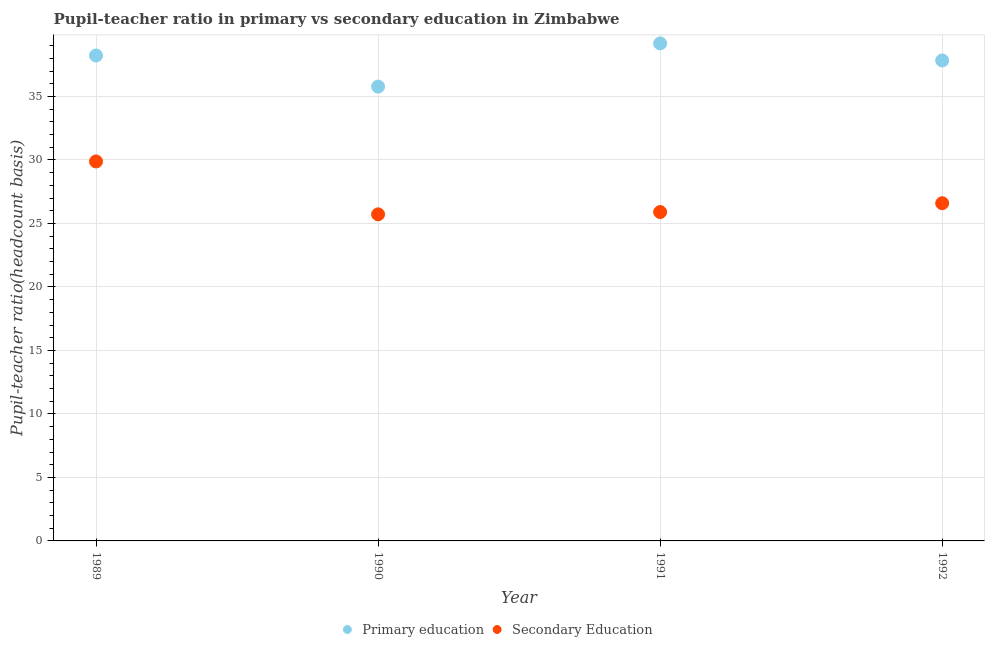What is the pupil-teacher ratio in primary education in 1990?
Offer a terse response. 35.78. Across all years, what is the maximum pupil teacher ratio on secondary education?
Keep it short and to the point. 29.88. Across all years, what is the minimum pupil-teacher ratio in primary education?
Provide a succinct answer. 35.78. In which year was the pupil-teacher ratio in primary education maximum?
Make the answer very short. 1991. In which year was the pupil teacher ratio on secondary education minimum?
Make the answer very short. 1990. What is the total pupil-teacher ratio in primary education in the graph?
Your answer should be compact. 151.01. What is the difference between the pupil teacher ratio on secondary education in 1991 and that in 1992?
Provide a short and direct response. -0.7. What is the difference between the pupil-teacher ratio in primary education in 1992 and the pupil teacher ratio on secondary education in 1991?
Offer a very short reply. 11.94. What is the average pupil teacher ratio on secondary education per year?
Make the answer very short. 27.02. In the year 1990, what is the difference between the pupil-teacher ratio in primary education and pupil teacher ratio on secondary education?
Provide a succinct answer. 10.06. In how many years, is the pupil teacher ratio on secondary education greater than 9?
Offer a very short reply. 4. What is the ratio of the pupil teacher ratio on secondary education in 1989 to that in 1991?
Offer a terse response. 1.15. What is the difference between the highest and the second highest pupil-teacher ratio in primary education?
Make the answer very short. 0.95. What is the difference between the highest and the lowest pupil teacher ratio on secondary education?
Offer a very short reply. 4.16. Is the sum of the pupil teacher ratio on secondary education in 1991 and 1992 greater than the maximum pupil-teacher ratio in primary education across all years?
Provide a succinct answer. Yes. How many dotlines are there?
Keep it short and to the point. 2. Are the values on the major ticks of Y-axis written in scientific E-notation?
Your answer should be very brief. No. Does the graph contain any zero values?
Give a very brief answer. No. Does the graph contain grids?
Your response must be concise. Yes. How many legend labels are there?
Your response must be concise. 2. How are the legend labels stacked?
Keep it short and to the point. Horizontal. What is the title of the graph?
Ensure brevity in your answer.  Pupil-teacher ratio in primary vs secondary education in Zimbabwe. Does "Food and tobacco" appear as one of the legend labels in the graph?
Offer a terse response. No. What is the label or title of the Y-axis?
Your response must be concise. Pupil-teacher ratio(headcount basis). What is the Pupil-teacher ratio(headcount basis) in Primary education in 1989?
Offer a very short reply. 38.22. What is the Pupil-teacher ratio(headcount basis) in Secondary Education in 1989?
Offer a terse response. 29.88. What is the Pupil-teacher ratio(headcount basis) in Primary education in 1990?
Keep it short and to the point. 35.78. What is the Pupil-teacher ratio(headcount basis) in Secondary Education in 1990?
Your response must be concise. 25.72. What is the Pupil-teacher ratio(headcount basis) in Primary education in 1991?
Your answer should be compact. 39.18. What is the Pupil-teacher ratio(headcount basis) in Secondary Education in 1991?
Your response must be concise. 25.9. What is the Pupil-teacher ratio(headcount basis) in Primary education in 1992?
Your answer should be compact. 37.83. What is the Pupil-teacher ratio(headcount basis) in Secondary Education in 1992?
Ensure brevity in your answer.  26.59. Across all years, what is the maximum Pupil-teacher ratio(headcount basis) in Primary education?
Your answer should be compact. 39.18. Across all years, what is the maximum Pupil-teacher ratio(headcount basis) of Secondary Education?
Your response must be concise. 29.88. Across all years, what is the minimum Pupil-teacher ratio(headcount basis) in Primary education?
Your answer should be very brief. 35.78. Across all years, what is the minimum Pupil-teacher ratio(headcount basis) in Secondary Education?
Make the answer very short. 25.72. What is the total Pupil-teacher ratio(headcount basis) of Primary education in the graph?
Your answer should be very brief. 151.01. What is the total Pupil-teacher ratio(headcount basis) in Secondary Education in the graph?
Make the answer very short. 108.09. What is the difference between the Pupil-teacher ratio(headcount basis) of Primary education in 1989 and that in 1990?
Ensure brevity in your answer.  2.45. What is the difference between the Pupil-teacher ratio(headcount basis) of Secondary Education in 1989 and that in 1990?
Your response must be concise. 4.16. What is the difference between the Pupil-teacher ratio(headcount basis) of Primary education in 1989 and that in 1991?
Offer a very short reply. -0.95. What is the difference between the Pupil-teacher ratio(headcount basis) in Secondary Education in 1989 and that in 1991?
Your answer should be very brief. 3.98. What is the difference between the Pupil-teacher ratio(headcount basis) of Primary education in 1989 and that in 1992?
Make the answer very short. 0.39. What is the difference between the Pupil-teacher ratio(headcount basis) of Secondary Education in 1989 and that in 1992?
Provide a succinct answer. 3.29. What is the difference between the Pupil-teacher ratio(headcount basis) in Primary education in 1990 and that in 1991?
Provide a succinct answer. -3.4. What is the difference between the Pupil-teacher ratio(headcount basis) of Secondary Education in 1990 and that in 1991?
Offer a very short reply. -0.18. What is the difference between the Pupil-teacher ratio(headcount basis) of Primary education in 1990 and that in 1992?
Offer a very short reply. -2.06. What is the difference between the Pupil-teacher ratio(headcount basis) in Secondary Education in 1990 and that in 1992?
Provide a short and direct response. -0.88. What is the difference between the Pupil-teacher ratio(headcount basis) of Primary education in 1991 and that in 1992?
Offer a terse response. 1.34. What is the difference between the Pupil-teacher ratio(headcount basis) of Secondary Education in 1991 and that in 1992?
Make the answer very short. -0.7. What is the difference between the Pupil-teacher ratio(headcount basis) in Primary education in 1989 and the Pupil-teacher ratio(headcount basis) in Secondary Education in 1990?
Your answer should be very brief. 12.51. What is the difference between the Pupil-teacher ratio(headcount basis) in Primary education in 1989 and the Pupil-teacher ratio(headcount basis) in Secondary Education in 1991?
Your answer should be very brief. 12.33. What is the difference between the Pupil-teacher ratio(headcount basis) of Primary education in 1989 and the Pupil-teacher ratio(headcount basis) of Secondary Education in 1992?
Your response must be concise. 11.63. What is the difference between the Pupil-teacher ratio(headcount basis) in Primary education in 1990 and the Pupil-teacher ratio(headcount basis) in Secondary Education in 1991?
Offer a terse response. 9.88. What is the difference between the Pupil-teacher ratio(headcount basis) of Primary education in 1990 and the Pupil-teacher ratio(headcount basis) of Secondary Education in 1992?
Offer a very short reply. 9.19. What is the difference between the Pupil-teacher ratio(headcount basis) in Primary education in 1991 and the Pupil-teacher ratio(headcount basis) in Secondary Education in 1992?
Offer a terse response. 12.58. What is the average Pupil-teacher ratio(headcount basis) of Primary education per year?
Your answer should be compact. 37.75. What is the average Pupil-teacher ratio(headcount basis) of Secondary Education per year?
Your answer should be compact. 27.02. In the year 1989, what is the difference between the Pupil-teacher ratio(headcount basis) in Primary education and Pupil-teacher ratio(headcount basis) in Secondary Education?
Make the answer very short. 8.34. In the year 1990, what is the difference between the Pupil-teacher ratio(headcount basis) of Primary education and Pupil-teacher ratio(headcount basis) of Secondary Education?
Your answer should be very brief. 10.06. In the year 1991, what is the difference between the Pupil-teacher ratio(headcount basis) of Primary education and Pupil-teacher ratio(headcount basis) of Secondary Education?
Your answer should be compact. 13.28. In the year 1992, what is the difference between the Pupil-teacher ratio(headcount basis) of Primary education and Pupil-teacher ratio(headcount basis) of Secondary Education?
Keep it short and to the point. 11.24. What is the ratio of the Pupil-teacher ratio(headcount basis) in Primary education in 1989 to that in 1990?
Ensure brevity in your answer.  1.07. What is the ratio of the Pupil-teacher ratio(headcount basis) in Secondary Education in 1989 to that in 1990?
Your response must be concise. 1.16. What is the ratio of the Pupil-teacher ratio(headcount basis) in Primary education in 1989 to that in 1991?
Keep it short and to the point. 0.98. What is the ratio of the Pupil-teacher ratio(headcount basis) of Secondary Education in 1989 to that in 1991?
Provide a short and direct response. 1.15. What is the ratio of the Pupil-teacher ratio(headcount basis) of Primary education in 1989 to that in 1992?
Provide a succinct answer. 1.01. What is the ratio of the Pupil-teacher ratio(headcount basis) in Secondary Education in 1989 to that in 1992?
Provide a succinct answer. 1.12. What is the ratio of the Pupil-teacher ratio(headcount basis) in Primary education in 1990 to that in 1991?
Provide a short and direct response. 0.91. What is the ratio of the Pupil-teacher ratio(headcount basis) of Primary education in 1990 to that in 1992?
Make the answer very short. 0.95. What is the ratio of the Pupil-teacher ratio(headcount basis) of Secondary Education in 1990 to that in 1992?
Your response must be concise. 0.97. What is the ratio of the Pupil-teacher ratio(headcount basis) in Primary education in 1991 to that in 1992?
Offer a very short reply. 1.04. What is the ratio of the Pupil-teacher ratio(headcount basis) in Secondary Education in 1991 to that in 1992?
Ensure brevity in your answer.  0.97. What is the difference between the highest and the second highest Pupil-teacher ratio(headcount basis) in Primary education?
Provide a short and direct response. 0.95. What is the difference between the highest and the second highest Pupil-teacher ratio(headcount basis) of Secondary Education?
Your response must be concise. 3.29. What is the difference between the highest and the lowest Pupil-teacher ratio(headcount basis) of Primary education?
Provide a succinct answer. 3.4. What is the difference between the highest and the lowest Pupil-teacher ratio(headcount basis) in Secondary Education?
Offer a very short reply. 4.16. 